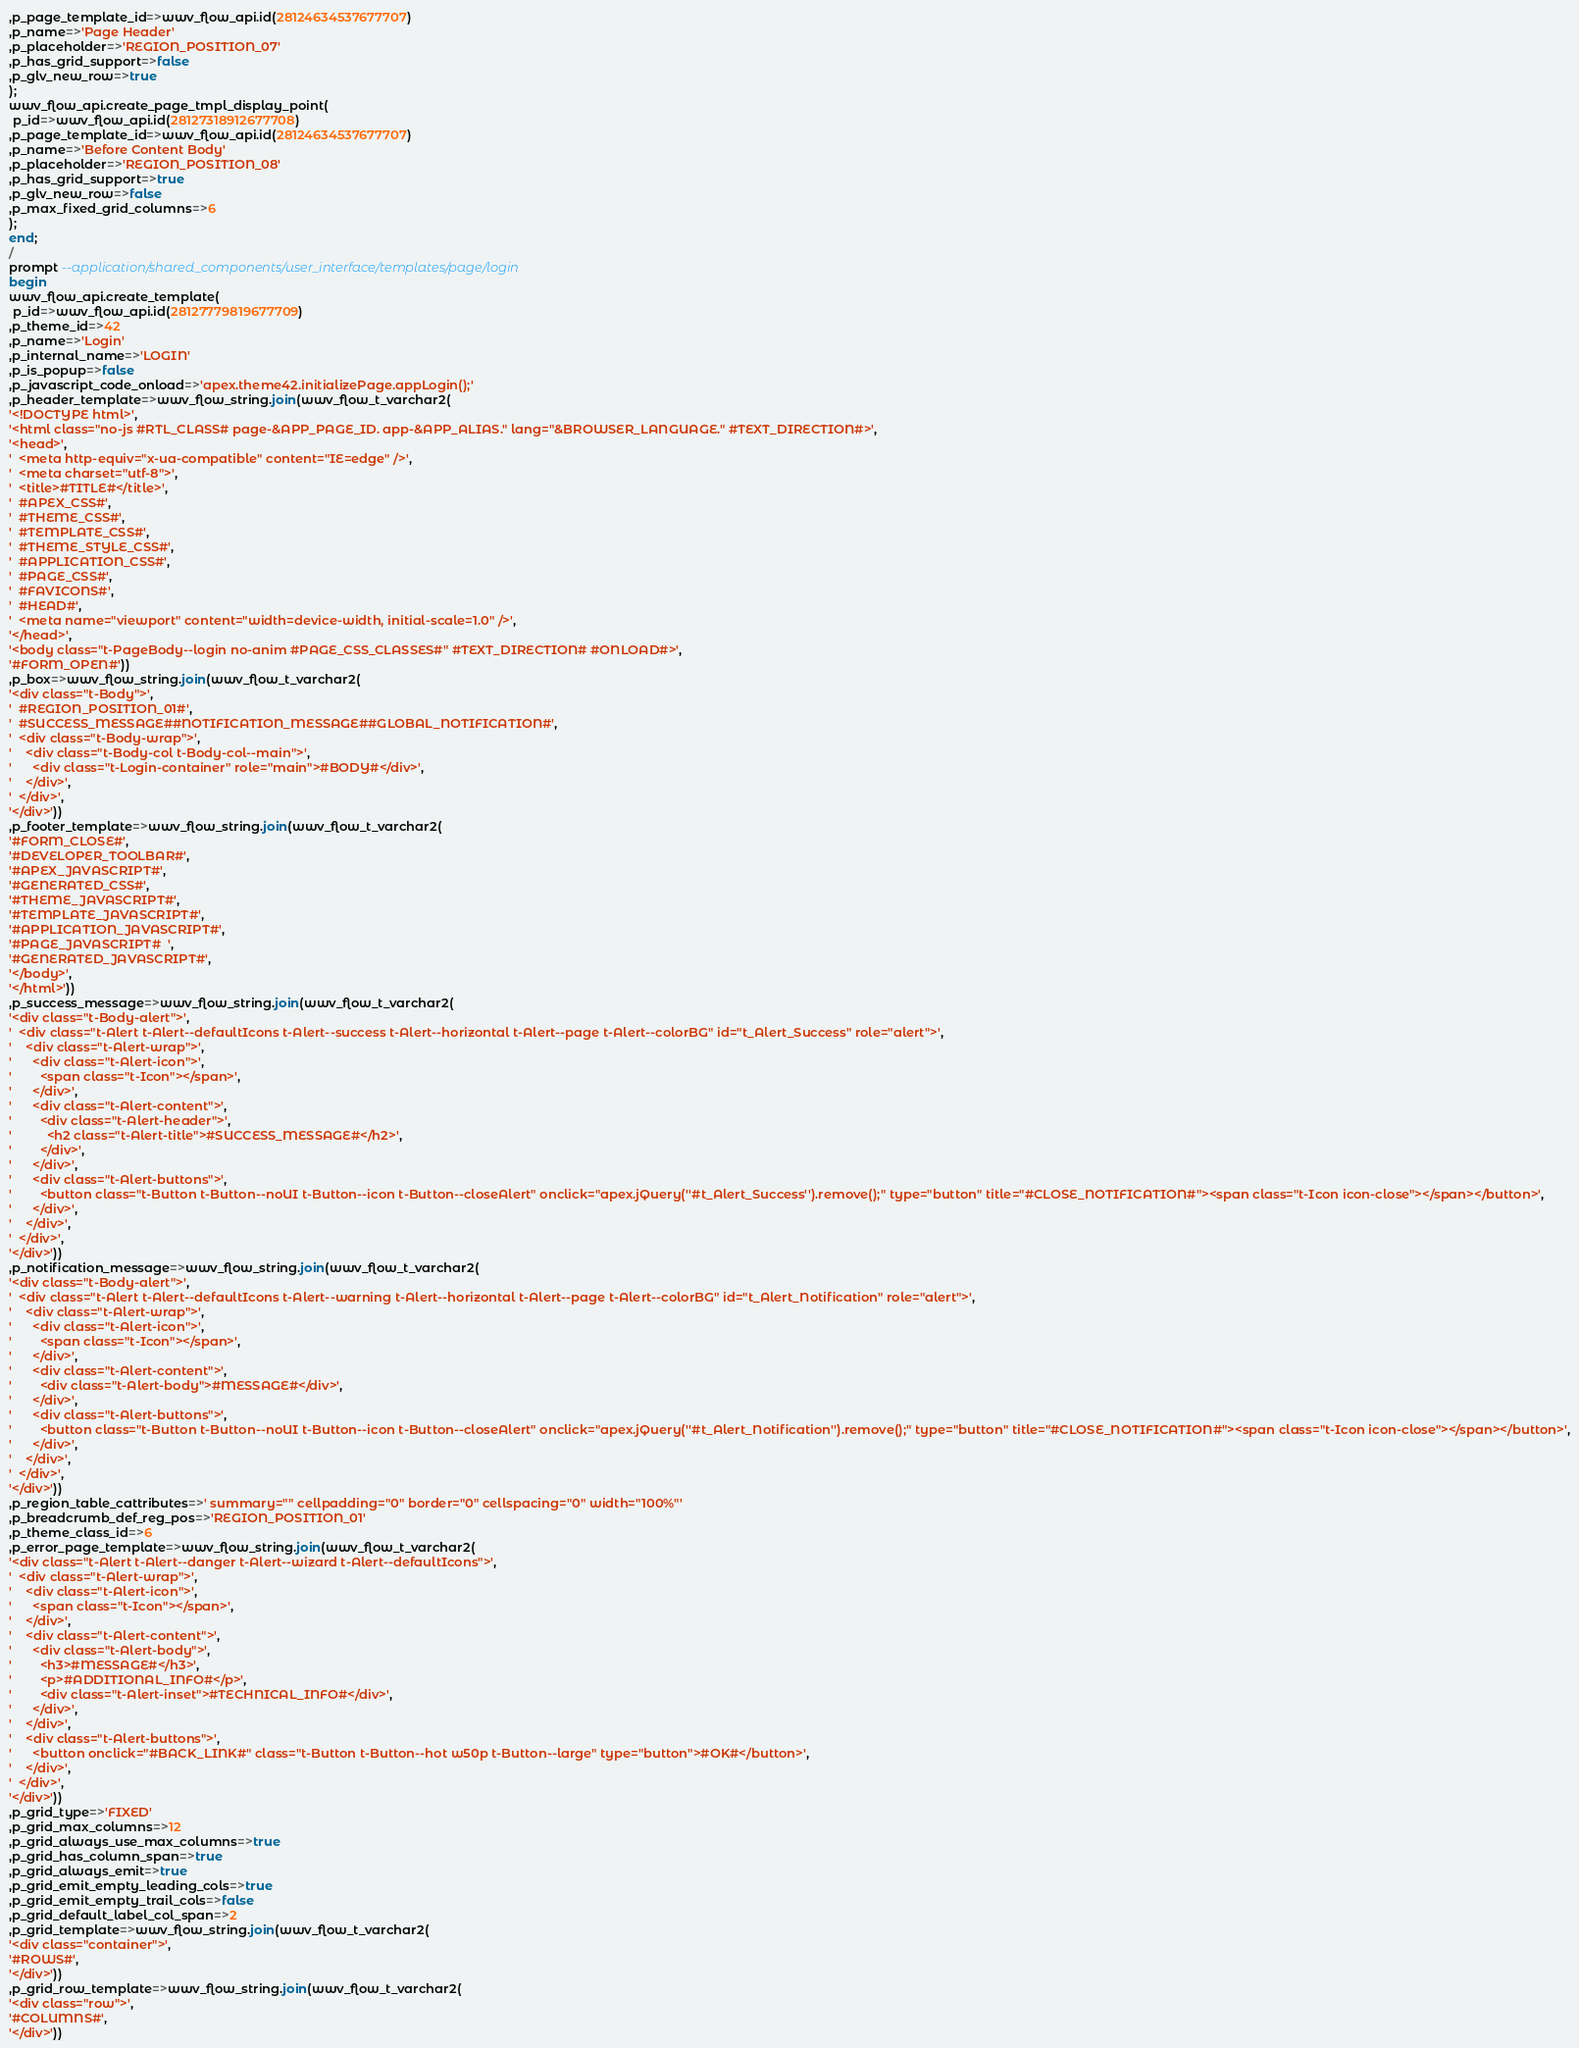<code> <loc_0><loc_0><loc_500><loc_500><_SQL_>,p_page_template_id=>wwv_flow_api.id(28124634537677707)
,p_name=>'Page Header'
,p_placeholder=>'REGION_POSITION_07'
,p_has_grid_support=>false
,p_glv_new_row=>true
);
wwv_flow_api.create_page_tmpl_display_point(
 p_id=>wwv_flow_api.id(28127318912677708)
,p_page_template_id=>wwv_flow_api.id(28124634537677707)
,p_name=>'Before Content Body'
,p_placeholder=>'REGION_POSITION_08'
,p_has_grid_support=>true
,p_glv_new_row=>false
,p_max_fixed_grid_columns=>6
);
end;
/
prompt --application/shared_components/user_interface/templates/page/login
begin
wwv_flow_api.create_template(
 p_id=>wwv_flow_api.id(28127779819677709)
,p_theme_id=>42
,p_name=>'Login'
,p_internal_name=>'LOGIN'
,p_is_popup=>false
,p_javascript_code_onload=>'apex.theme42.initializePage.appLogin();'
,p_header_template=>wwv_flow_string.join(wwv_flow_t_varchar2(
'<!DOCTYPE html>',
'<html class="no-js #RTL_CLASS# page-&APP_PAGE_ID. app-&APP_ALIAS." lang="&BROWSER_LANGUAGE." #TEXT_DIRECTION#>',
'<head>',
'  <meta http-equiv="x-ua-compatible" content="IE=edge" />',
'  <meta charset="utf-8">',
'  <title>#TITLE#</title>',
'  #APEX_CSS#',
'  #THEME_CSS#',
'  #TEMPLATE_CSS#',
'  #THEME_STYLE_CSS#',
'  #APPLICATION_CSS#',
'  #PAGE_CSS#',
'  #FAVICONS#',
'  #HEAD#',
'  <meta name="viewport" content="width=device-width, initial-scale=1.0" />',
'</head>',
'<body class="t-PageBody--login no-anim #PAGE_CSS_CLASSES#" #TEXT_DIRECTION# #ONLOAD#>',
'#FORM_OPEN#'))
,p_box=>wwv_flow_string.join(wwv_flow_t_varchar2(
'<div class="t-Body">',
'  #REGION_POSITION_01#',
'  #SUCCESS_MESSAGE##NOTIFICATION_MESSAGE##GLOBAL_NOTIFICATION#',
'  <div class="t-Body-wrap">',
'    <div class="t-Body-col t-Body-col--main">',
'      <div class="t-Login-container" role="main">#BODY#</div>',
'    </div>',
'  </div>',
'</div>'))
,p_footer_template=>wwv_flow_string.join(wwv_flow_t_varchar2(
'#FORM_CLOSE#',
'#DEVELOPER_TOOLBAR#',
'#APEX_JAVASCRIPT#',
'#GENERATED_CSS#',
'#THEME_JAVASCRIPT#',
'#TEMPLATE_JAVASCRIPT#',
'#APPLICATION_JAVASCRIPT#',
'#PAGE_JAVASCRIPT#  ',
'#GENERATED_JAVASCRIPT#',
'</body>',
'</html>'))
,p_success_message=>wwv_flow_string.join(wwv_flow_t_varchar2(
'<div class="t-Body-alert">',
'  <div class="t-Alert t-Alert--defaultIcons t-Alert--success t-Alert--horizontal t-Alert--page t-Alert--colorBG" id="t_Alert_Success" role="alert">',
'    <div class="t-Alert-wrap">',
'      <div class="t-Alert-icon">',
'        <span class="t-Icon"></span>',
'      </div>',
'      <div class="t-Alert-content">',
'        <div class="t-Alert-header">',
'          <h2 class="t-Alert-title">#SUCCESS_MESSAGE#</h2>',
'        </div>',
'      </div>',
'      <div class="t-Alert-buttons">',
'        <button class="t-Button t-Button--noUI t-Button--icon t-Button--closeAlert" onclick="apex.jQuery(''#t_Alert_Success'').remove();" type="button" title="#CLOSE_NOTIFICATION#"><span class="t-Icon icon-close"></span></button>',
'      </div>',
'    </div>',
'  </div>',
'</div>'))
,p_notification_message=>wwv_flow_string.join(wwv_flow_t_varchar2(
'<div class="t-Body-alert">',
'  <div class="t-Alert t-Alert--defaultIcons t-Alert--warning t-Alert--horizontal t-Alert--page t-Alert--colorBG" id="t_Alert_Notification" role="alert">',
'    <div class="t-Alert-wrap">',
'      <div class="t-Alert-icon">',
'        <span class="t-Icon"></span>',
'      </div>',
'      <div class="t-Alert-content">',
'        <div class="t-Alert-body">#MESSAGE#</div>',
'      </div>',
'      <div class="t-Alert-buttons">',
'        <button class="t-Button t-Button--noUI t-Button--icon t-Button--closeAlert" onclick="apex.jQuery(''#t_Alert_Notification'').remove();" type="button" title="#CLOSE_NOTIFICATION#"><span class="t-Icon icon-close"></span></button>',
'      </div>',
'    </div>',
'  </div>',
'</div>'))
,p_region_table_cattributes=>' summary="" cellpadding="0" border="0" cellspacing="0" width="100%"'
,p_breadcrumb_def_reg_pos=>'REGION_POSITION_01'
,p_theme_class_id=>6
,p_error_page_template=>wwv_flow_string.join(wwv_flow_t_varchar2(
'<div class="t-Alert t-Alert--danger t-Alert--wizard t-Alert--defaultIcons">',
'  <div class="t-Alert-wrap">',
'    <div class="t-Alert-icon">',
'      <span class="t-Icon"></span>',
'    </div>',
'    <div class="t-Alert-content">',
'      <div class="t-Alert-body">',
'        <h3>#MESSAGE#</h3>',
'        <p>#ADDITIONAL_INFO#</p>',
'        <div class="t-Alert-inset">#TECHNICAL_INFO#</div>',
'      </div>',
'    </div>',
'    <div class="t-Alert-buttons">',
'      <button onclick="#BACK_LINK#" class="t-Button t-Button--hot w50p t-Button--large" type="button">#OK#</button>',
'    </div>',
'  </div>',
'</div>'))
,p_grid_type=>'FIXED'
,p_grid_max_columns=>12
,p_grid_always_use_max_columns=>true
,p_grid_has_column_span=>true
,p_grid_always_emit=>true
,p_grid_emit_empty_leading_cols=>true
,p_grid_emit_empty_trail_cols=>false
,p_grid_default_label_col_span=>2
,p_grid_template=>wwv_flow_string.join(wwv_flow_t_varchar2(
'<div class="container">',
'#ROWS#',
'</div>'))
,p_grid_row_template=>wwv_flow_string.join(wwv_flow_t_varchar2(
'<div class="row">',
'#COLUMNS#',
'</div>'))</code> 